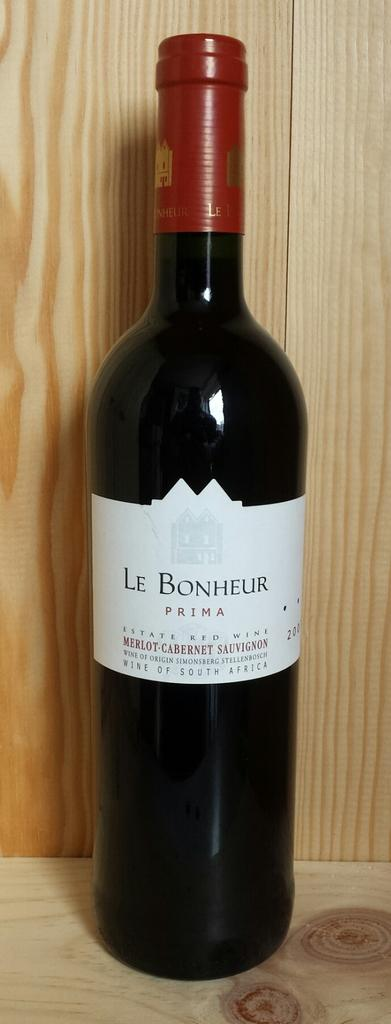<image>
Provide a brief description of the given image. A bottle of Le Bonheur Merlot Prima Cabernet Sauvignon from South Africa is in front of a wood background. 